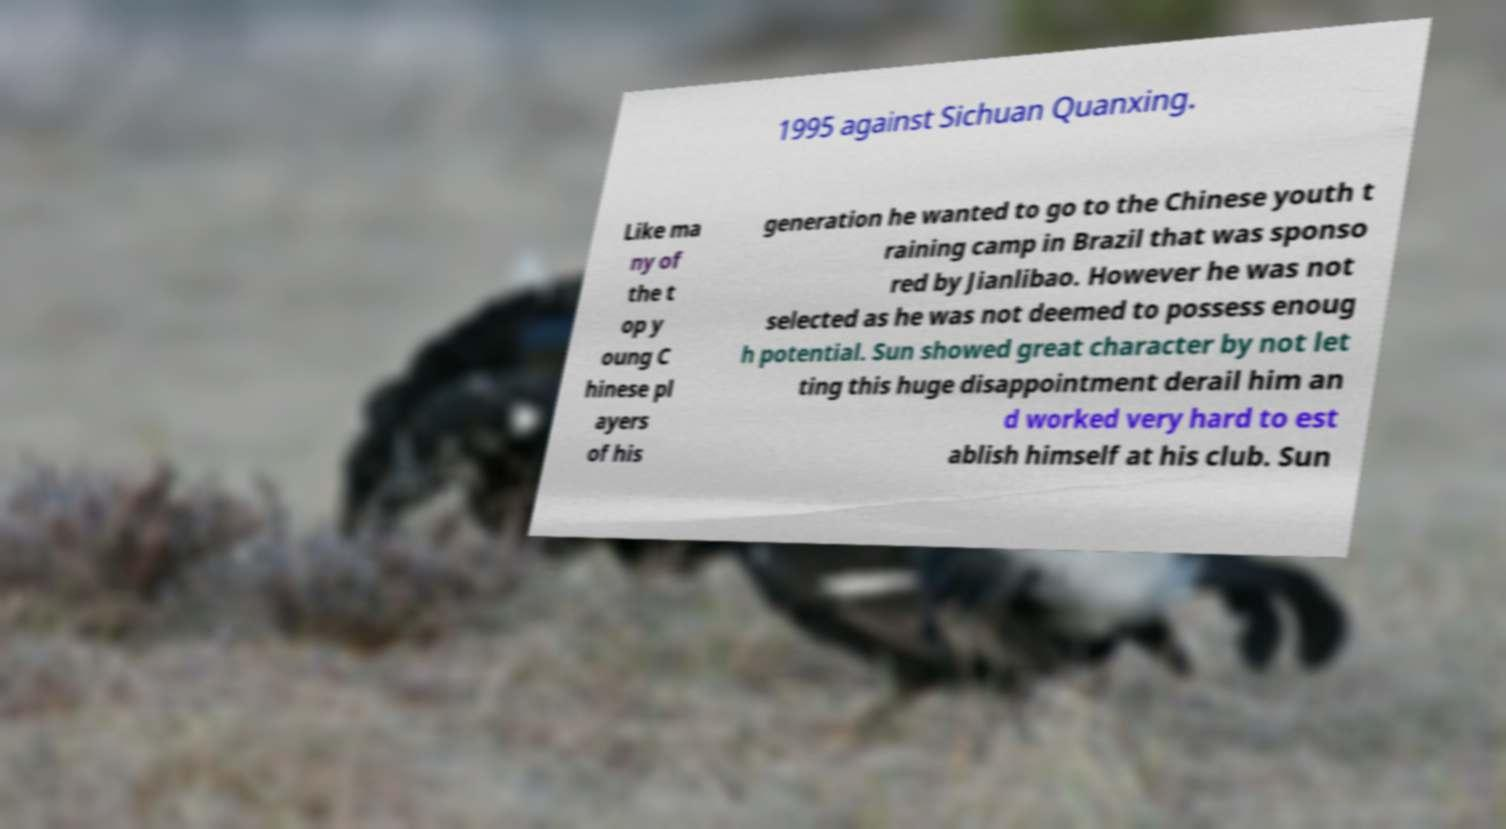Please read and relay the text visible in this image. What does it say? 1995 against Sichuan Quanxing. Like ma ny of the t op y oung C hinese pl ayers of his generation he wanted to go to the Chinese youth t raining camp in Brazil that was sponso red by Jianlibao. However he was not selected as he was not deemed to possess enoug h potential. Sun showed great character by not let ting this huge disappointment derail him an d worked very hard to est ablish himself at his club. Sun 